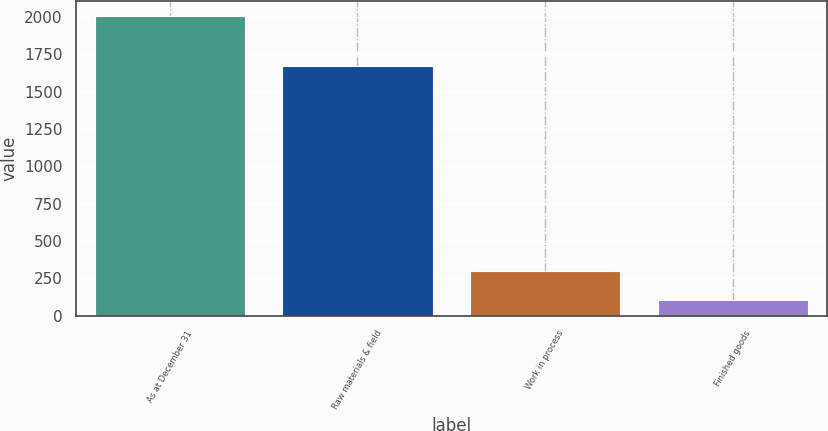Convert chart. <chart><loc_0><loc_0><loc_500><loc_500><bar_chart><fcel>As at December 31<fcel>Raw materials & field<fcel>Work in process<fcel>Finished goods<nl><fcel>2008<fcel>1674<fcel>298.9<fcel>109<nl></chart> 